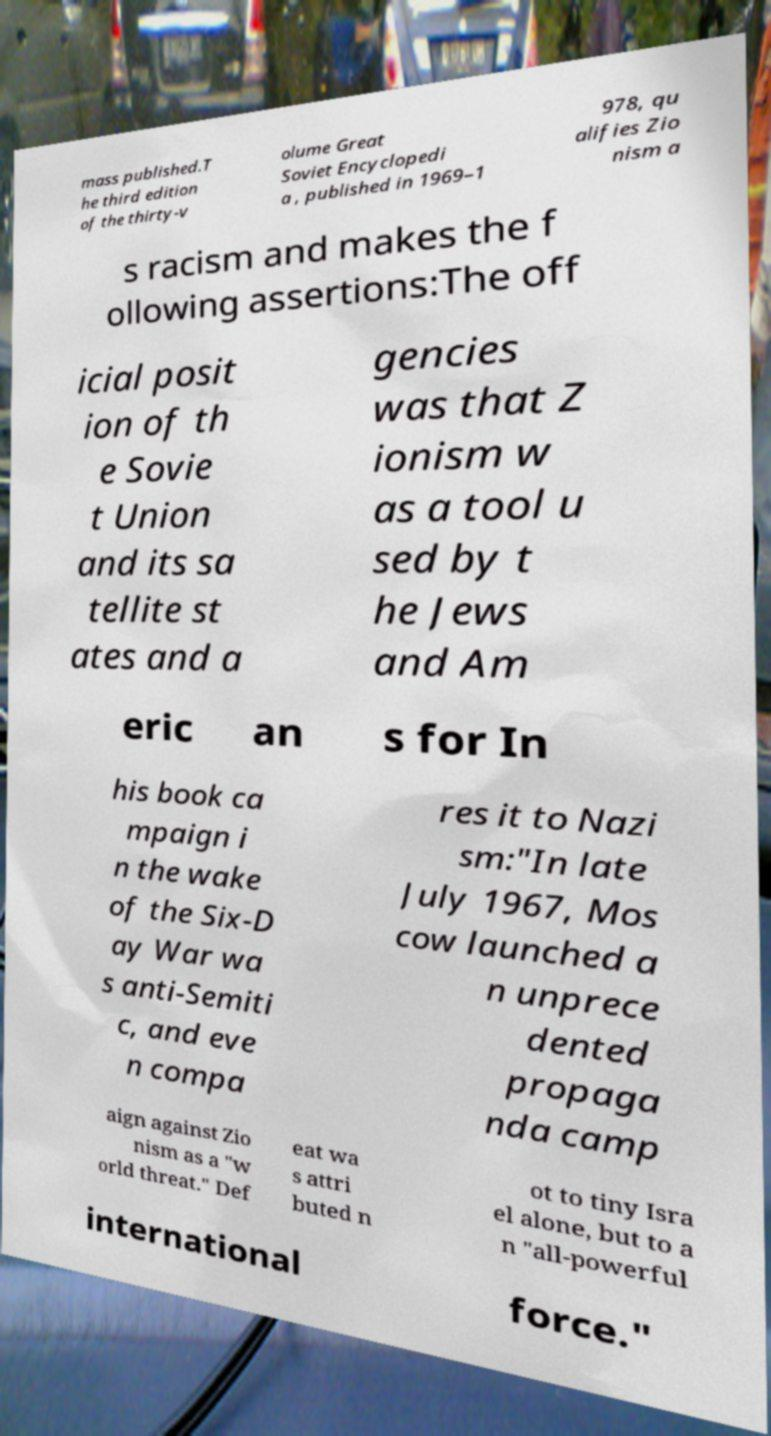Can you read and provide the text displayed in the image?This photo seems to have some interesting text. Can you extract and type it out for me? mass published.T he third edition of the thirty-v olume Great Soviet Encyclopedi a , published in 1969–1 978, qu alifies Zio nism a s racism and makes the f ollowing assertions:The off icial posit ion of th e Sovie t Union and its sa tellite st ates and a gencies was that Z ionism w as a tool u sed by t he Jews and Am eric an s for In his book ca mpaign i n the wake of the Six-D ay War wa s anti-Semiti c, and eve n compa res it to Nazi sm:"In late July 1967, Mos cow launched a n unprece dented propaga nda camp aign against Zio nism as a "w orld threat." Def eat wa s attri buted n ot to tiny Isra el alone, but to a n "all-powerful international force." 